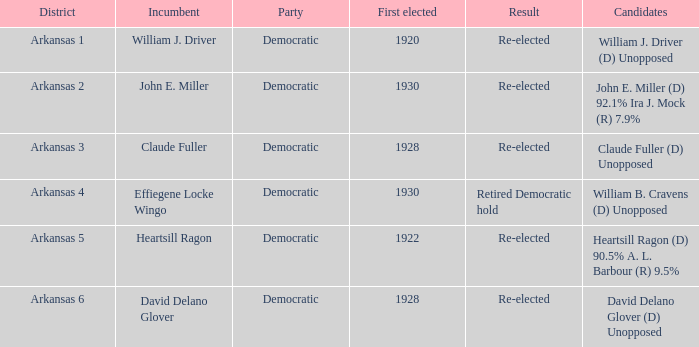In how many districts was the incumbent David Delano Glover?  1.0. 